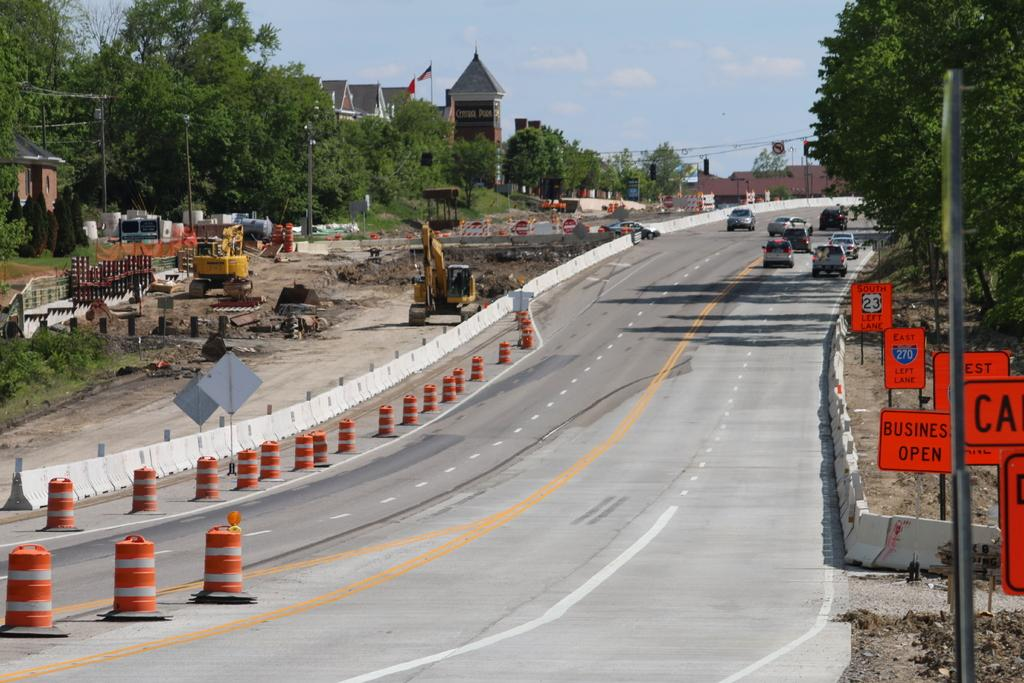<image>
Create a compact narrative representing the image presented. Long and empty high way with orange signs that say Business Open. 